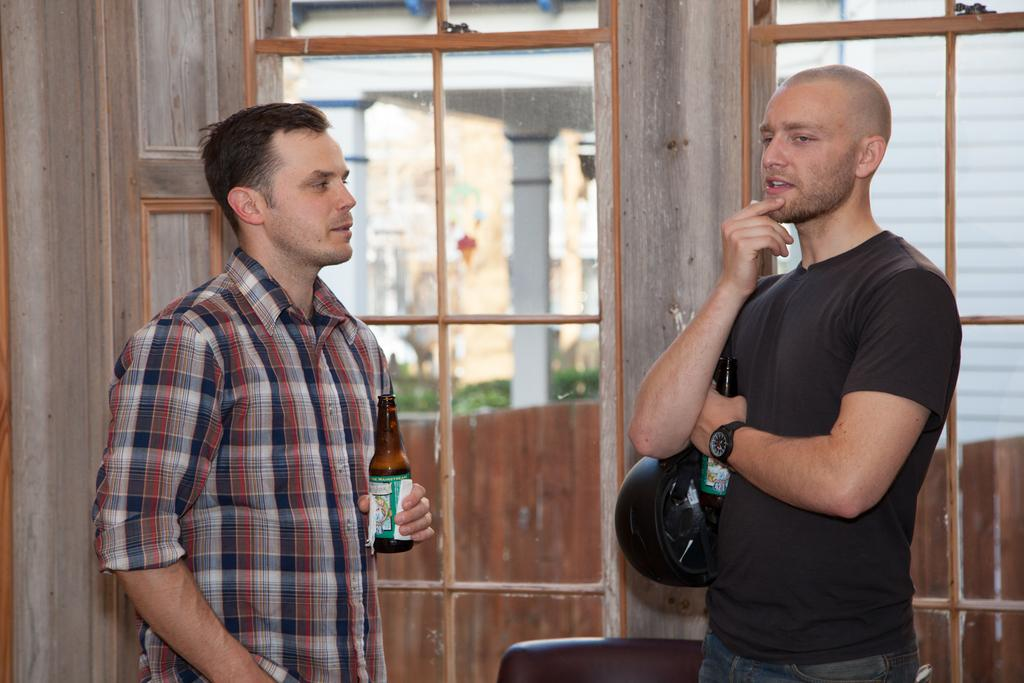Who or what is present in the image? There are people in the image. What are the people holding in the image? The people are holding bottles. What architectural features can be seen in the image? There is a door and windows in the image. What type of powder is being used to reach an agreement in the image? There is no indication of any powder or agreement in the image; it simply shows people holding bottles. 